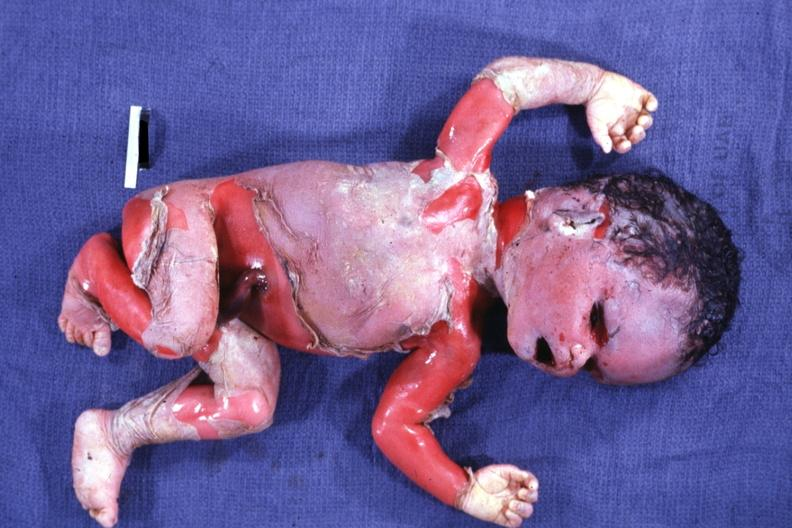does this image show external view of advanced state?
Answer the question using a single word or phrase. Yes 